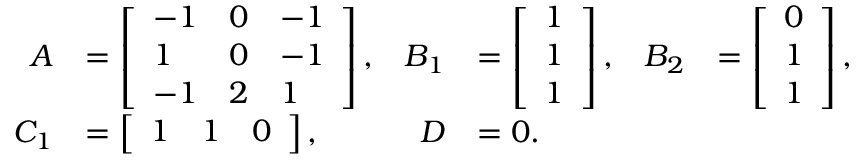<formula> <loc_0><loc_0><loc_500><loc_500>\begin{array} { r l r l r l } { A } & { = \left [ \begin{array} { l l l } { - 1 } & { 0 } & { - 1 } \\ { 1 } & { 0 } & { - 1 } \\ { - 1 } & { 2 } & { 1 } \end{array} \right ] , } & { B _ { 1 } } & { = \left [ \begin{array} { l } { 1 } \\ { 1 } \\ { 1 } \end{array} \right ] , } & { B _ { 2 } } & { = \left [ \begin{array} { l } { 0 } \\ { 1 } \\ { 1 } \end{array} \right ] , } \\ { C _ { 1 } } & { = \left [ \begin{array} { l l l } { 1 } & { 1 } & { 0 } \end{array} \right ] , } & { D } & { = 0 . } \end{array}</formula> 